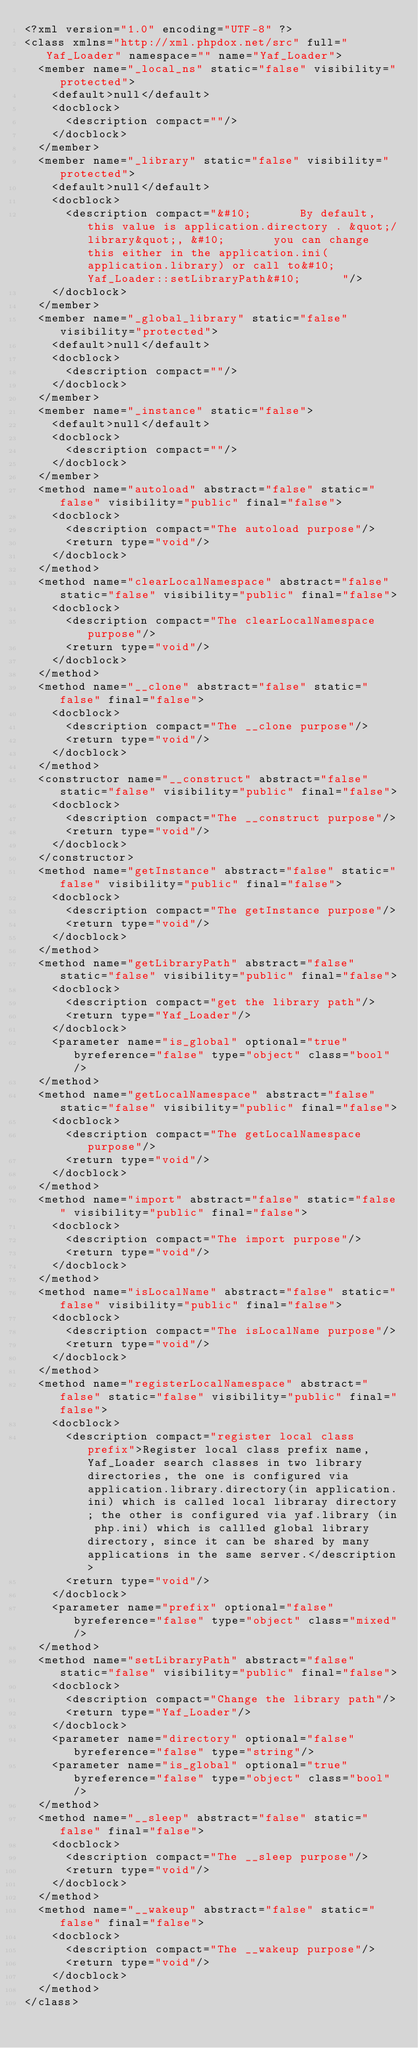Convert code to text. <code><loc_0><loc_0><loc_500><loc_500><_XML_><?xml version="1.0" encoding="UTF-8" ?>
<class xmlns="http://xml.phpdox.net/src" full="Yaf_Loader" namespace="" name="Yaf_Loader">
  <member name="_local_ns" static="false" visibility="protected">
    <default>null</default>
    <docblock>
      <description compact=""/>
    </docblock>
  </member>
  <member name="_library" static="false" visibility="protected">
    <default>null</default>
    <docblock>
      <description compact="&#10;       By default, this value is application.directory . &quot;/library&quot;, &#10;       you can change this either in the application.ini(application.library) or call to&#10;      Yaf_Loader::setLibraryPath&#10;      "/>
    </docblock>
  </member>
  <member name="_global_library" static="false" visibility="protected">
    <default>null</default>
    <docblock>
      <description compact=""/>
    </docblock>
  </member>
  <member name="_instance" static="false">
    <default>null</default>
    <docblock>
      <description compact=""/>
    </docblock>
  </member>
  <method name="autoload" abstract="false" static="false" visibility="public" final="false">
    <docblock>
      <description compact="The autoload purpose"/>
      <return type="void"/>
    </docblock>
  </method>
  <method name="clearLocalNamespace" abstract="false" static="false" visibility="public" final="false">
    <docblock>
      <description compact="The clearLocalNamespace purpose"/>
      <return type="void"/>
    </docblock>
  </method>
  <method name="__clone" abstract="false" static="false" final="false">
    <docblock>
      <description compact="The __clone purpose"/>
      <return type="void"/>
    </docblock>
  </method>
  <constructor name="__construct" abstract="false" static="false" visibility="public" final="false">
    <docblock>
      <description compact="The __construct purpose"/>
      <return type="void"/>
    </docblock>
  </constructor>
  <method name="getInstance" abstract="false" static="false" visibility="public" final="false">
    <docblock>
      <description compact="The getInstance purpose"/>
      <return type="void"/>
    </docblock>
  </method>
  <method name="getLibraryPath" abstract="false" static="false" visibility="public" final="false">
    <docblock>
      <description compact="get the library path"/>
      <return type="Yaf_Loader"/>
    </docblock>
    <parameter name="is_global" optional="true" byreference="false" type="object" class="bool"/>
  </method>
  <method name="getLocalNamespace" abstract="false" static="false" visibility="public" final="false">
    <docblock>
      <description compact="The getLocalNamespace purpose"/>
      <return type="void"/>
    </docblock>
  </method>
  <method name="import" abstract="false" static="false" visibility="public" final="false">
    <docblock>
      <description compact="The import purpose"/>
      <return type="void"/>
    </docblock>
  </method>
  <method name="isLocalName" abstract="false" static="false" visibility="public" final="false">
    <docblock>
      <description compact="The isLocalName purpose"/>
      <return type="void"/>
    </docblock>
  </method>
  <method name="registerLocalNamespace" abstract="false" static="false" visibility="public" final="false">
    <docblock>
      <description compact="register local class prefix">Register local class prefix name, Yaf_Loader search classes in two library directories, the one is configured via application.library.directory(in application.ini) which is called local libraray directory; the other is configured via yaf.library (in php.ini) which is callled global library directory, since it can be shared by many applications in the same server.</description>
      <return type="void"/>
    </docblock>
    <parameter name="prefix" optional="false" byreference="false" type="object" class="mixed"/>
  </method>
  <method name="setLibraryPath" abstract="false" static="false" visibility="public" final="false">
    <docblock>
      <description compact="Change the library path"/>
      <return type="Yaf_Loader"/>
    </docblock>
    <parameter name="directory" optional="false" byreference="false" type="string"/>
    <parameter name="is_global" optional="true" byreference="false" type="object" class="bool"/>
  </method>
  <method name="__sleep" abstract="false" static="false" final="false">
    <docblock>
      <description compact="The __sleep purpose"/>
      <return type="void"/>
    </docblock>
  </method>
  <method name="__wakeup" abstract="false" static="false" final="false">
    <docblock>
      <description compact="The __wakeup purpose"/>
      <return type="void"/>
    </docblock>
  </method>
</class>
</code> 